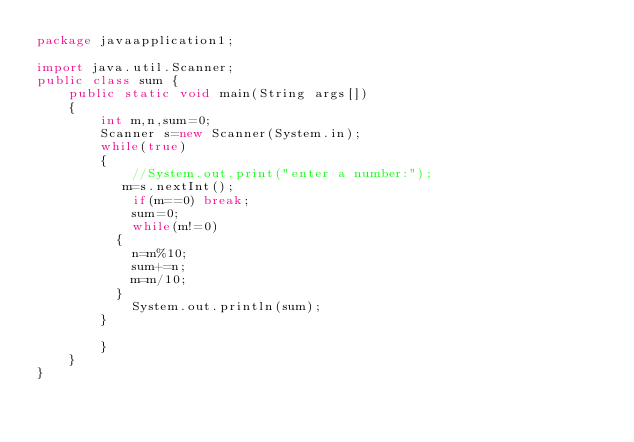Convert code to text. <code><loc_0><loc_0><loc_500><loc_500><_Java_>package javaapplication1;

import java.util.Scanner;
public class sum {
    public static void main(String args[])
    {
        int m,n,sum=0;
        Scanner s=new Scanner(System.in);
        while(true)
        {
            //System.out.print("enter a number:");
           m=s.nextInt();
            if(m==0) break;
            sum=0;
            while(m!=0)
          {
            n=m%10;
            sum+=n;
            m=m/10;
          }
            System.out.println(sum);
        }
        
        }
    }
}

</code> 